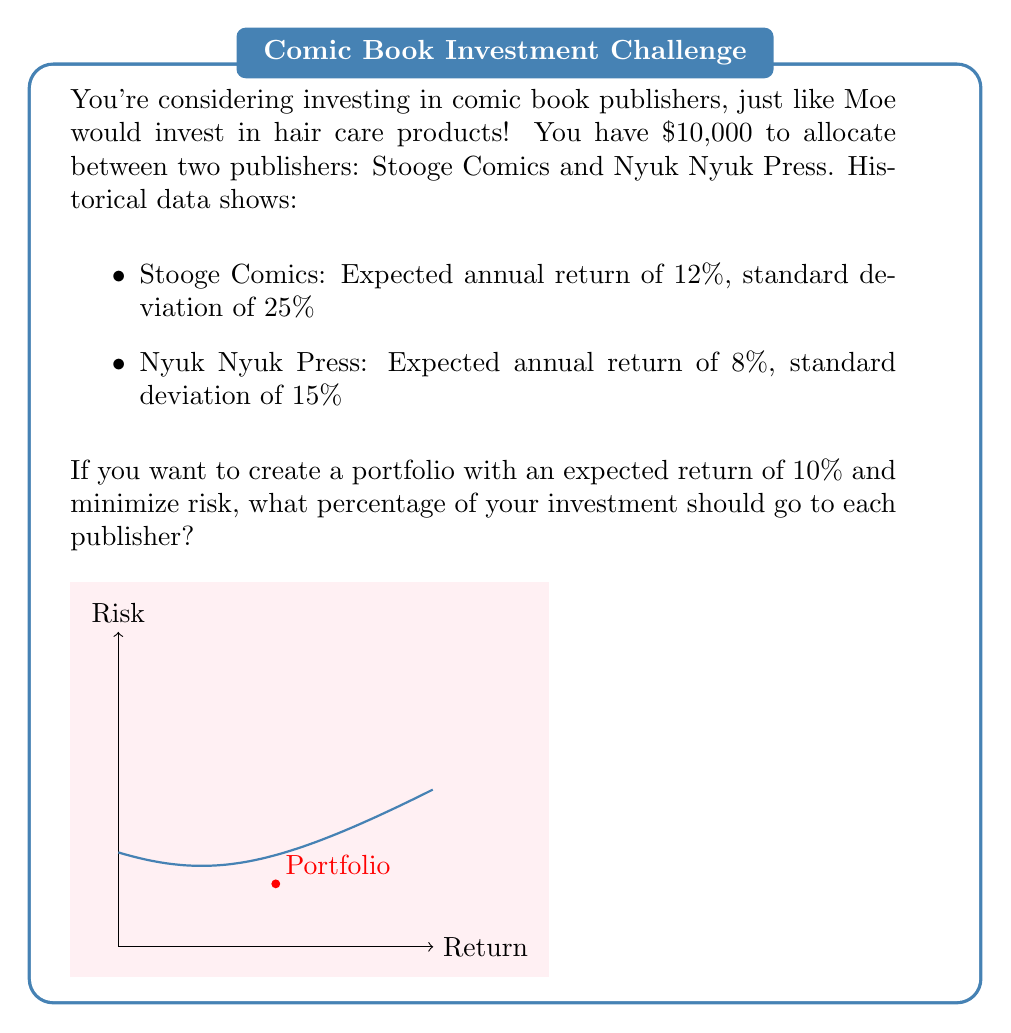Can you solve this math problem? Let's approach this step-by-step, you knuckleheads!

1) Let $x$ be the proportion invested in Stooge Comics. Then $(1-x)$ is invested in Nyuk Nyuk Press.

2) The expected return of the portfolio is:
   $$E(R_p) = 0.12x + 0.08(1-x) = 0.10$$

3) Solve this equation:
   $$0.12x + 0.08 - 0.08x = 0.10$$
   $$0.04x = 0.02$$
   $$x = 0.5$$

4) To minimize risk, we use the portfolio variance formula:
   $$\sigma_p^2 = x^2\sigma_1^2 + (1-x)^2\sigma_2^2 + 2x(1-x)\rho\sigma_1\sigma_2$$

   Where $\rho$ is the correlation coefficient. Assuming no correlation ($\rho = 0$) for simplicity:

   $$\sigma_p^2 = (0.5)^2(0.25)^2 + (0.5)^2(0.15)^2$$

5) The standard deviation (risk) of the portfolio is:
   $$\sigma_p = \sqrt{0.5^2(0.25^2) + 0.5^2(0.15^2)} \approx 0.1458 \text{ or } 14.58\%$$

This portfolio achieves the desired 10% return with minimum risk, given the constraints.
Answer: 50% in Stooge Comics, 50% in Nyuk Nyuk Press 